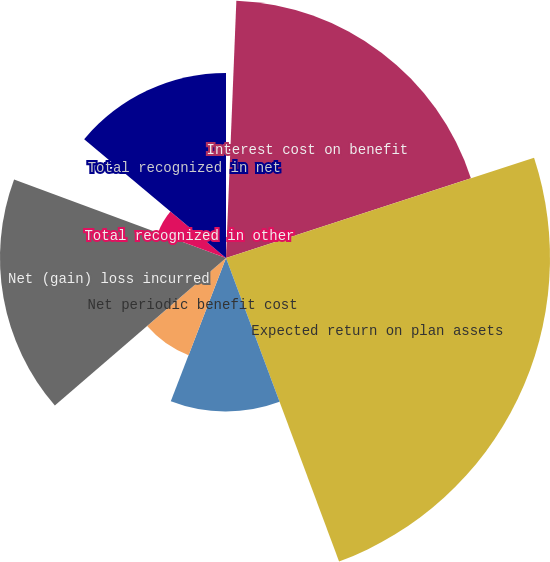Convert chart. <chart><loc_0><loc_0><loc_500><loc_500><pie_chart><fcel>Service cost<fcel>Interest cost on benefit<fcel>Expected return on plan assets<fcel>Amortization of net loss<fcel>Net periodic benefit cost<fcel>Net (gain) loss incurred<fcel>Total recognized in other<fcel>Total recognized in net<nl><fcel>0.64%<fcel>19.35%<fcel>24.34%<fcel>11.53%<fcel>7.82%<fcel>16.98%<fcel>5.45%<fcel>13.9%<nl></chart> 